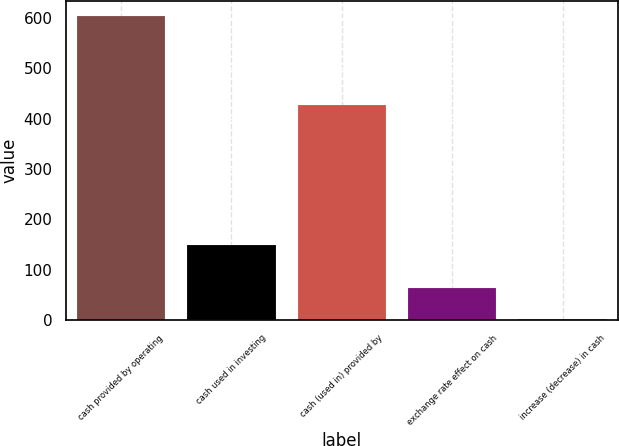Convert chart to OTSL. <chart><loc_0><loc_0><loc_500><loc_500><bar_chart><fcel>cash provided by operating<fcel>cash used in investing<fcel>cash (used in) provided by<fcel>exchange rate effect on cash<fcel>increase (decrease) in cash<nl><fcel>602.8<fcel>149.4<fcel>427<fcel>62.89<fcel>2.9<nl></chart> 